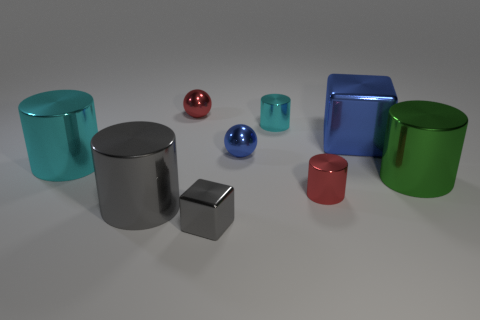The object that is both on the left side of the gray cube and behind the large cyan metallic thing is what color?
Make the answer very short. Red. What is the shape of the object that is the same color as the large shiny cube?
Keep it short and to the point. Sphere. There is a blue thing that is on the right side of the metallic ball that is in front of the red shiny sphere; how big is it?
Offer a terse response. Large. How many cylinders are either tiny cyan things or large metallic things?
Make the answer very short. 4. What color is the metal cube that is the same size as the red ball?
Offer a very short reply. Gray. What is the shape of the tiny red shiny thing that is in front of the cyan cylinder that is to the left of the gray cylinder?
Offer a terse response. Cylinder. Does the block in front of the green cylinder have the same size as the small cyan cylinder?
Provide a short and direct response. Yes. How many other things are there of the same material as the tiny cube?
Keep it short and to the point. 8. What number of purple things are either large cubes or metal cubes?
Give a very brief answer. 0. There is a metallic sphere that is the same color as the large metal block; what size is it?
Your answer should be compact. Small. 